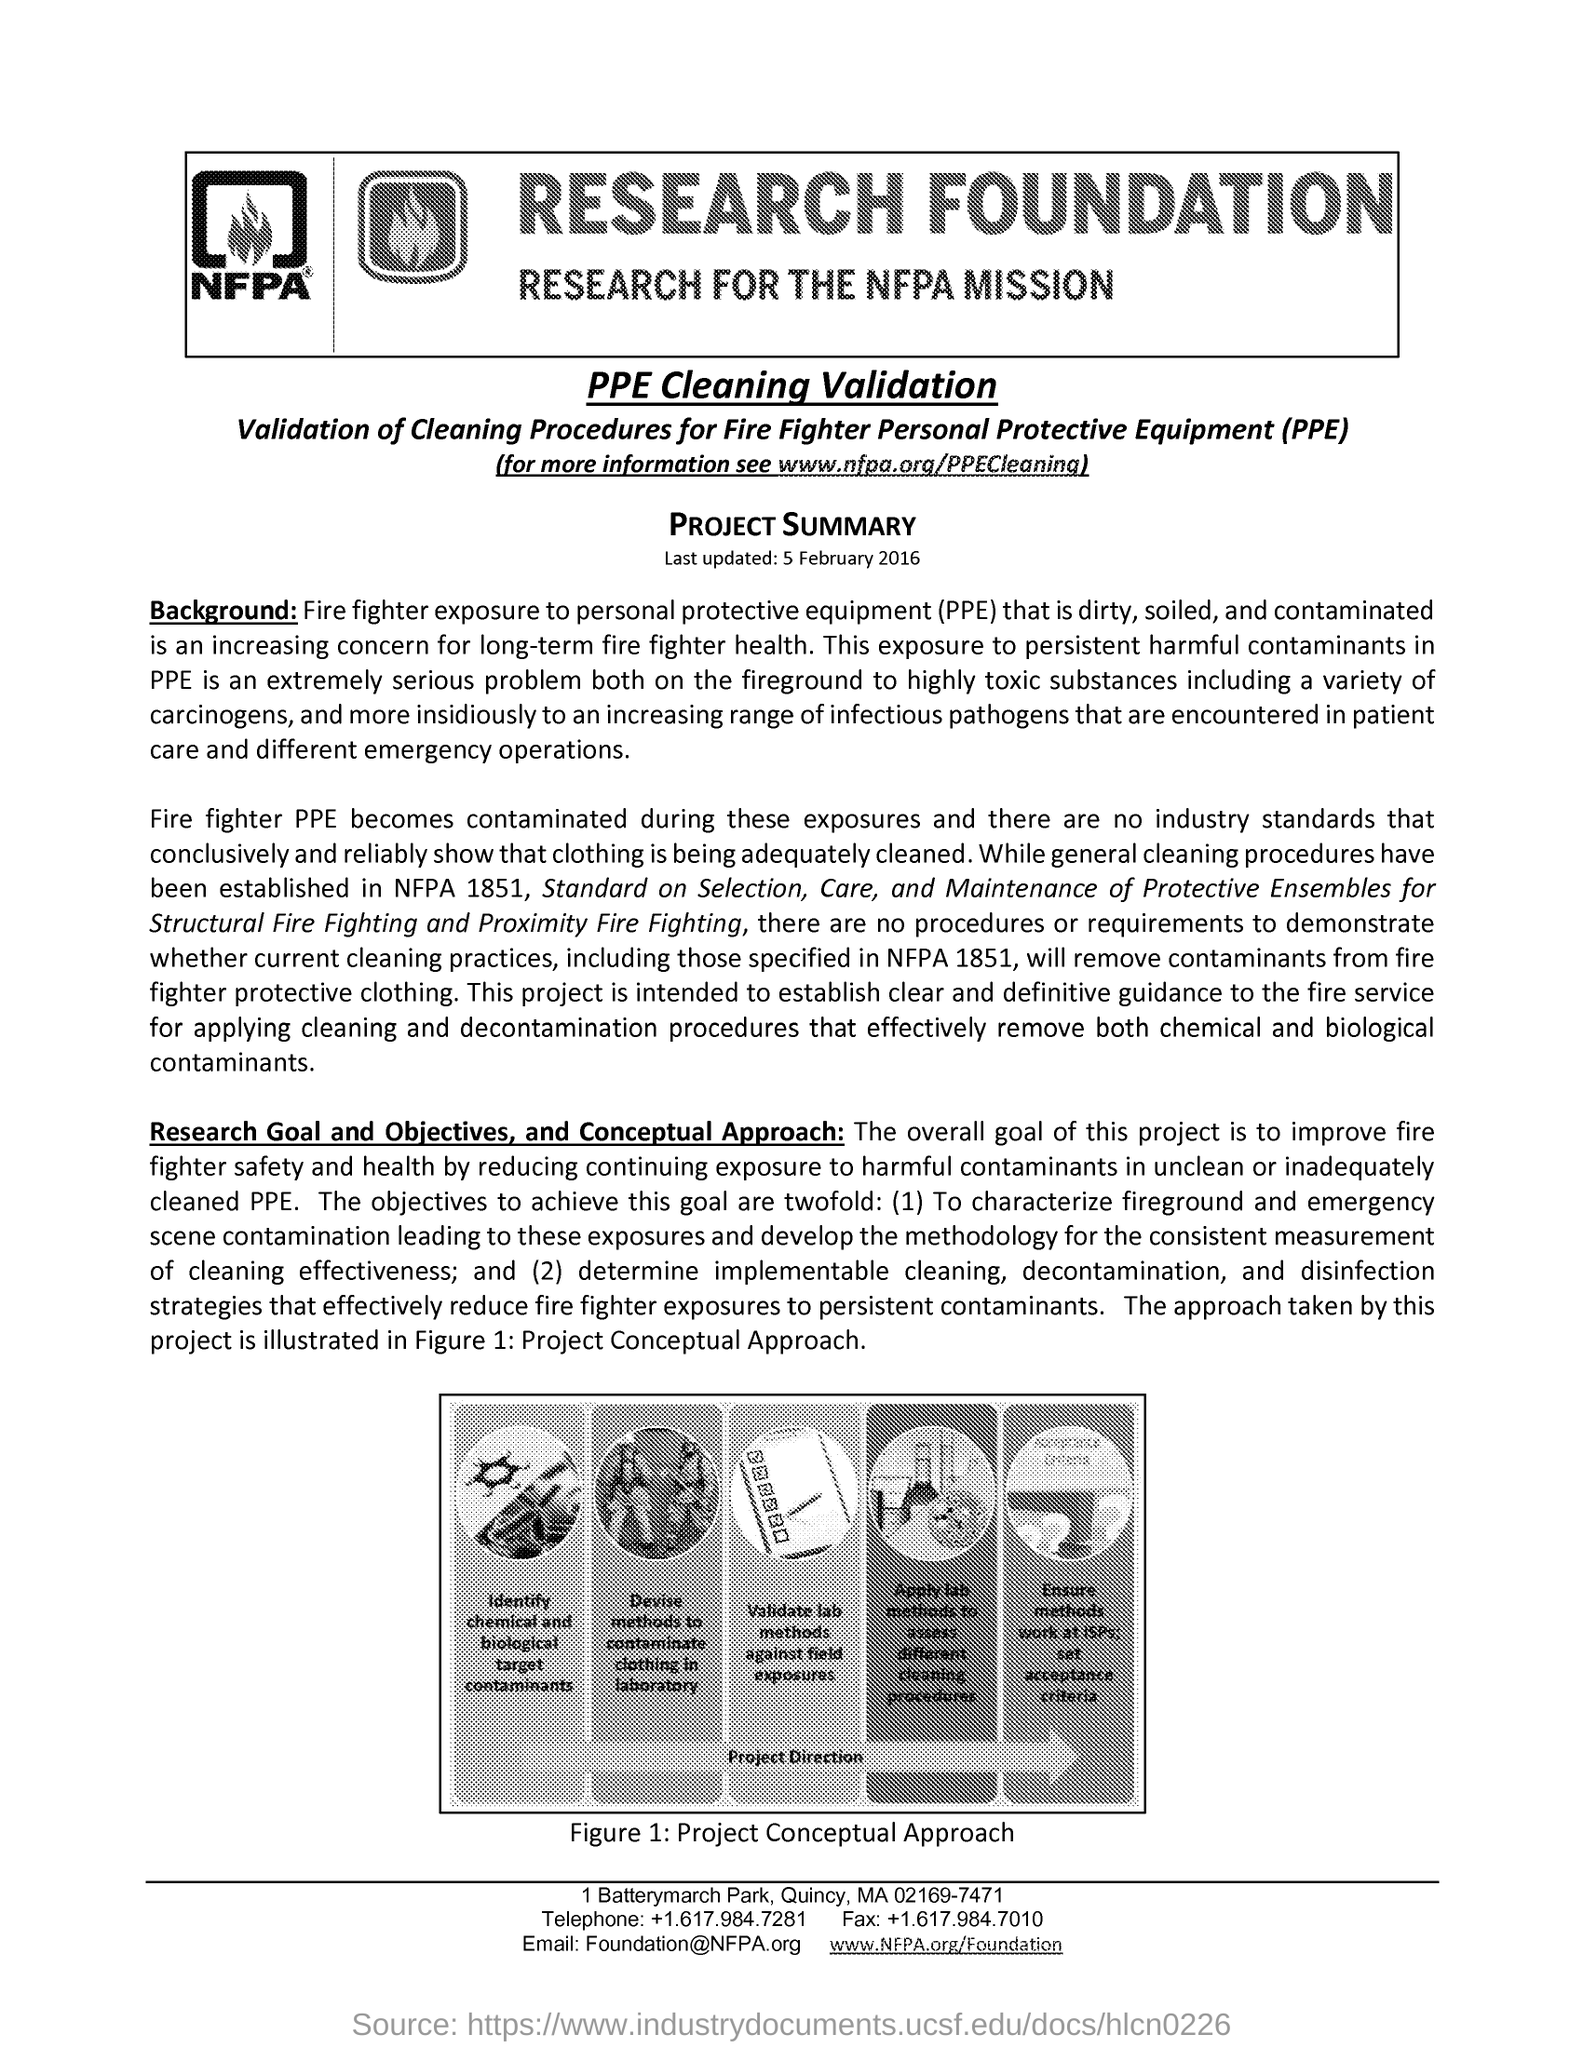What does Figure 1 represents?
Offer a terse response. Project Conceptual Approach. What is the fullform of PPE?
Your response must be concise. Personal Protective Equipment. What is the last updated date mentioned in this document?
Keep it short and to the point. 5 February 2016. 